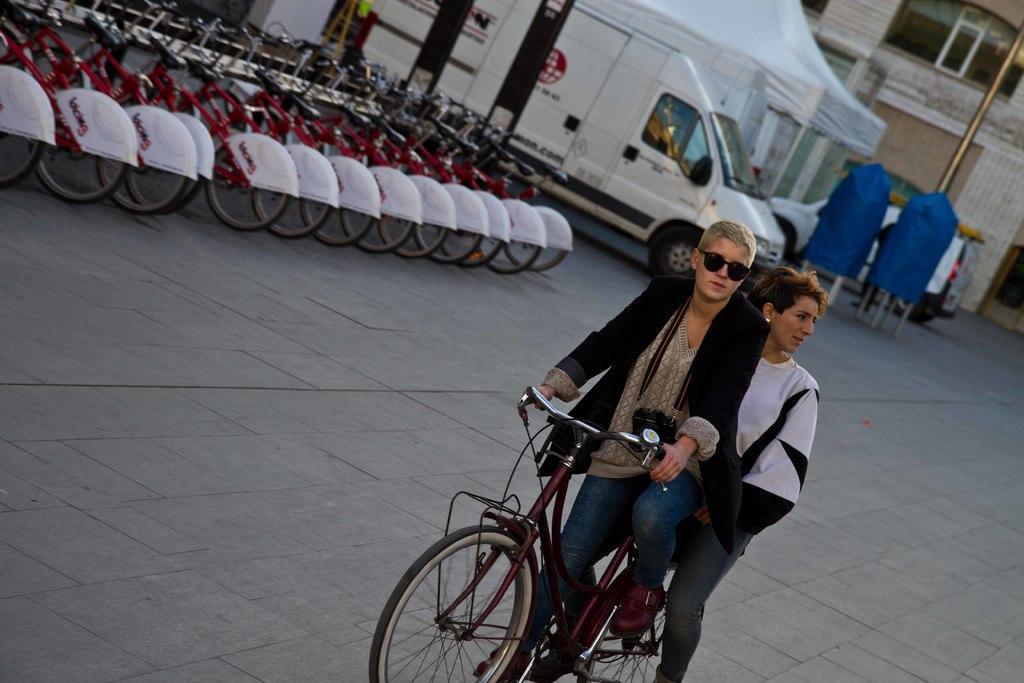Describe this image in one or two sentences. In the middle there are two persons sitting on the bicycle. On the left there are many bicycles. In the background there is a vehicle ,tent ,pole and building. 